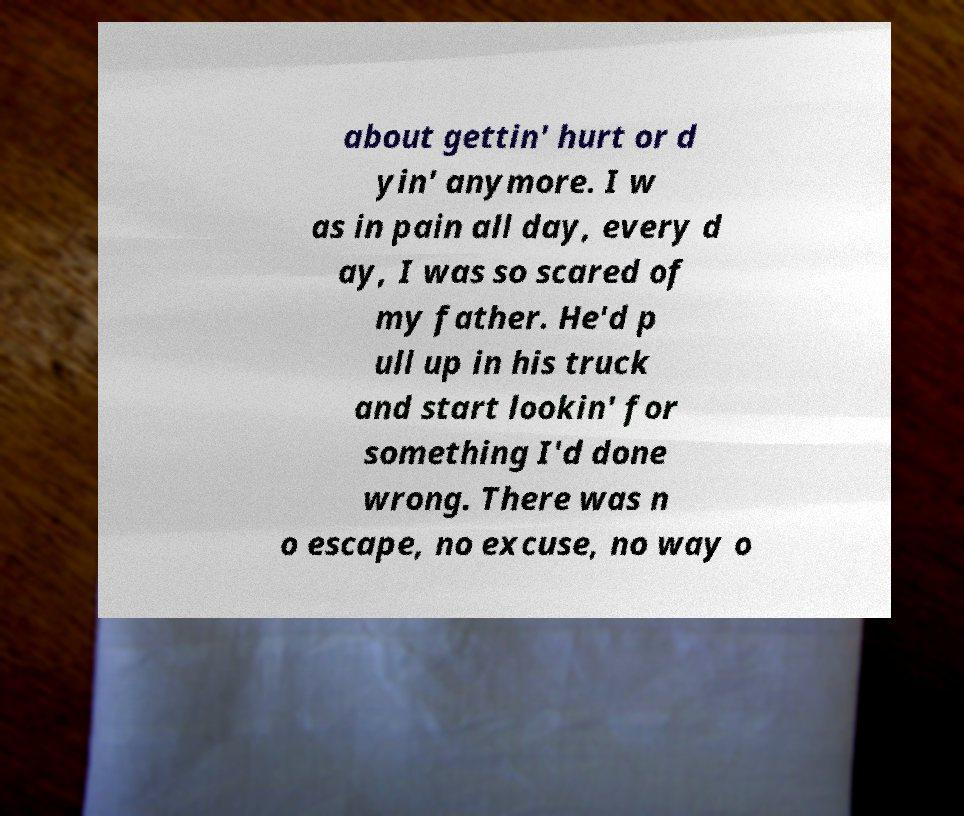There's text embedded in this image that I need extracted. Can you transcribe it verbatim? about gettin' hurt or d yin' anymore. I w as in pain all day, every d ay, I was so scared of my father. He'd p ull up in his truck and start lookin' for something I'd done wrong. There was n o escape, no excuse, no way o 